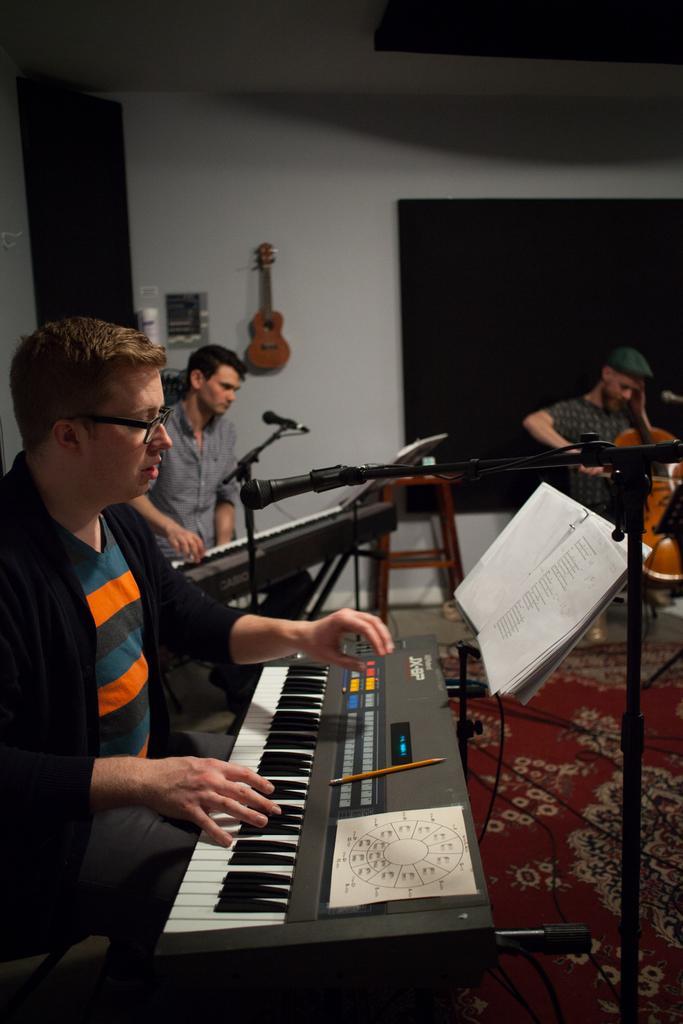Can you describe this image briefly? Here we can see a group of people are sitting on the chair, and playing musical instruments, and here is the book,and here is the microphone and stand, and here is the wall and guitar on it. 